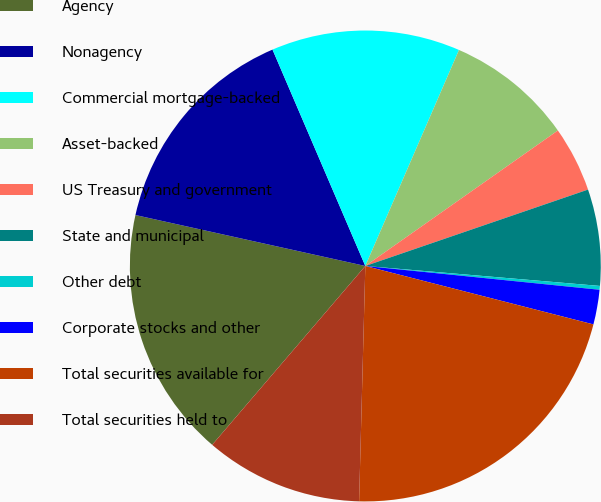Convert chart. <chart><loc_0><loc_0><loc_500><loc_500><pie_chart><fcel>Agency<fcel>Nonagency<fcel>Commercial mortgage-backed<fcel>Asset-backed<fcel>US Treasury and government<fcel>State and municipal<fcel>Other debt<fcel>Corporate stocks and other<fcel>Total securities available for<fcel>Total securities held to<nl><fcel>17.2%<fcel>15.08%<fcel>12.96%<fcel>8.73%<fcel>4.5%<fcel>6.61%<fcel>0.26%<fcel>2.38%<fcel>21.43%<fcel>10.85%<nl></chart> 